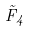<formula> <loc_0><loc_0><loc_500><loc_500>\tilde { F } _ { 4 }</formula> 